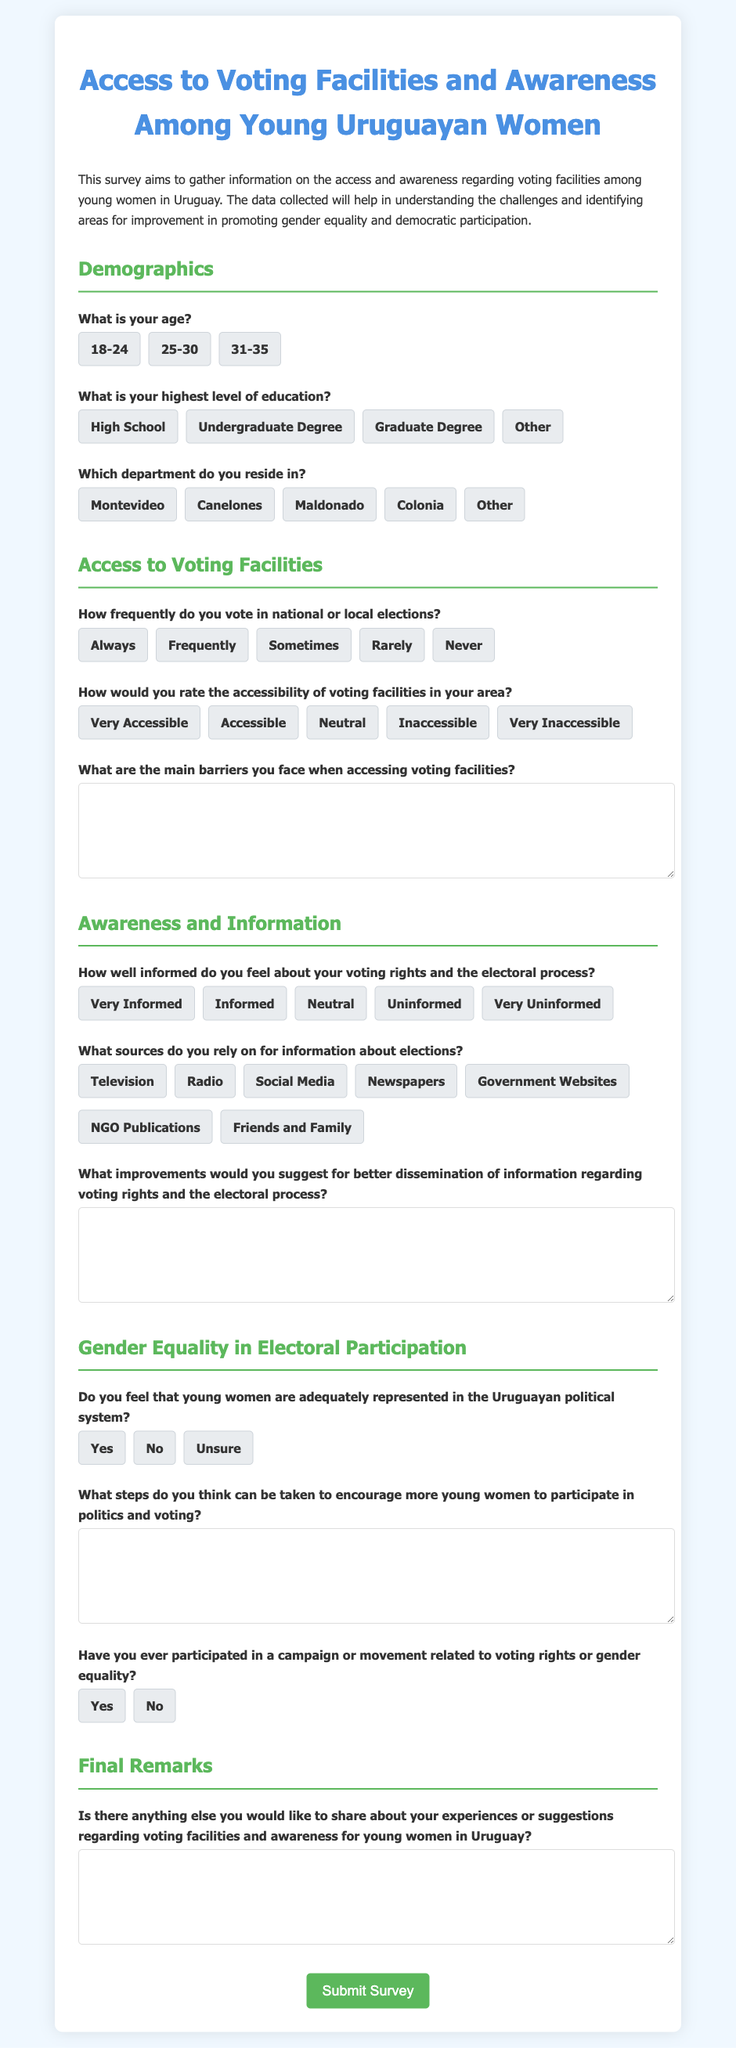What is the title of the survey? The title is presented at the top of the document within an h1 tag.
Answer: Access to Voting Facilities and Awareness Among Young Uruguayan Women What age range options are provided in the survey? The age range options are found in the demographics section of the form.
Answer: 18-24, 25-30, 31-35 How many demographics questions are included in the form? The number of demographics questions can be counted in the Demographics section.
Answer: 3 What is one of the sources listed for information about elections? This information is located in the Awareness and Information section where sources are queried.
Answer: Social Media What is the main purpose of the survey? The main purpose is described in the introductory paragraph of the document.
Answer: Gather information on access and awareness regarding voting facilities What type of feedback does the survey seek in the final remarks section? The final remarks section requests additional comments or suggestions regarding voting facilities and awareness.
Answer: Experiences or suggestions regarding voting facilities and awareness 